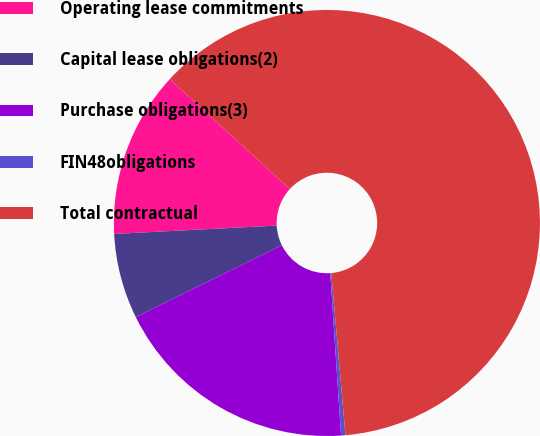<chart> <loc_0><loc_0><loc_500><loc_500><pie_chart><fcel>Operating lease commitments<fcel>Capital lease obligations(2)<fcel>Purchase obligations(3)<fcel>FIN48obligations<fcel>Total contractual<nl><fcel>12.62%<fcel>6.47%<fcel>18.77%<fcel>0.33%<fcel>61.81%<nl></chart> 